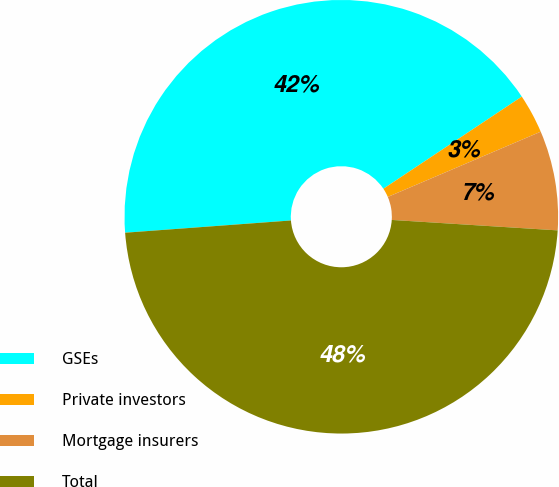Convert chart to OTSL. <chart><loc_0><loc_0><loc_500><loc_500><pie_chart><fcel>GSEs<fcel>Private investors<fcel>Mortgage insurers<fcel>Total<nl><fcel>41.83%<fcel>2.93%<fcel>7.42%<fcel>47.83%<nl></chart> 